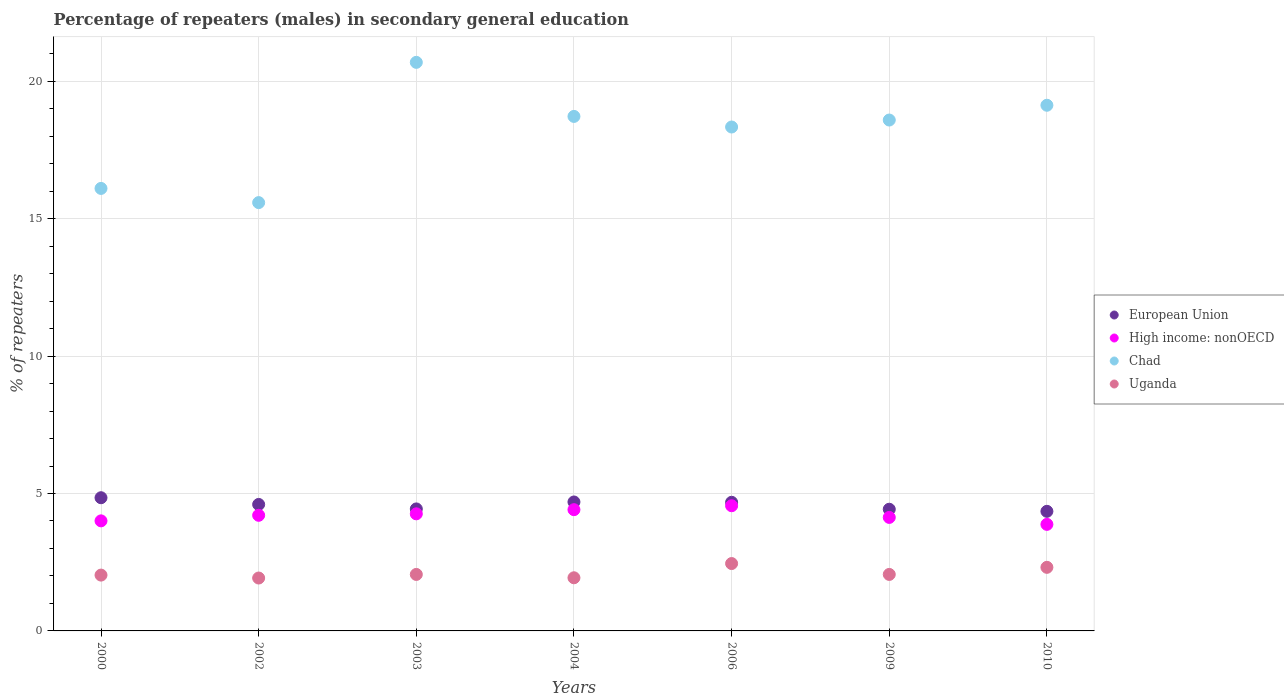How many different coloured dotlines are there?
Your response must be concise. 4. What is the percentage of male repeaters in Chad in 2009?
Ensure brevity in your answer.  18.59. Across all years, what is the maximum percentage of male repeaters in Uganda?
Make the answer very short. 2.45. Across all years, what is the minimum percentage of male repeaters in European Union?
Offer a very short reply. 4.35. In which year was the percentage of male repeaters in High income: nonOECD maximum?
Keep it short and to the point. 2006. What is the total percentage of male repeaters in High income: nonOECD in the graph?
Ensure brevity in your answer.  29.44. What is the difference between the percentage of male repeaters in Uganda in 2000 and that in 2006?
Make the answer very short. -0.42. What is the difference between the percentage of male repeaters in Chad in 2000 and the percentage of male repeaters in High income: nonOECD in 2009?
Provide a short and direct response. 11.97. What is the average percentage of male repeaters in Chad per year?
Provide a short and direct response. 18.16. In the year 2009, what is the difference between the percentage of male repeaters in High income: nonOECD and percentage of male repeaters in Uganda?
Provide a succinct answer. 2.07. In how many years, is the percentage of male repeaters in Uganda greater than 8 %?
Offer a terse response. 0. What is the ratio of the percentage of male repeaters in Uganda in 2003 to that in 2010?
Offer a terse response. 0.89. Is the percentage of male repeaters in High income: nonOECD in 2002 less than that in 2010?
Give a very brief answer. No. Is the difference between the percentage of male repeaters in High income: nonOECD in 2002 and 2006 greater than the difference between the percentage of male repeaters in Uganda in 2002 and 2006?
Ensure brevity in your answer.  Yes. What is the difference between the highest and the second highest percentage of male repeaters in High income: nonOECD?
Ensure brevity in your answer.  0.14. What is the difference between the highest and the lowest percentage of male repeaters in High income: nonOECD?
Provide a short and direct response. 0.68. Is the sum of the percentage of male repeaters in Uganda in 2009 and 2010 greater than the maximum percentage of male repeaters in High income: nonOECD across all years?
Offer a very short reply. No. Is it the case that in every year, the sum of the percentage of male repeaters in Uganda and percentage of male repeaters in Chad  is greater than the sum of percentage of male repeaters in High income: nonOECD and percentage of male repeaters in European Union?
Keep it short and to the point. Yes. Is it the case that in every year, the sum of the percentage of male repeaters in Uganda and percentage of male repeaters in Chad  is greater than the percentage of male repeaters in European Union?
Make the answer very short. Yes. What is the difference between two consecutive major ticks on the Y-axis?
Your response must be concise. 5. How many legend labels are there?
Your answer should be very brief. 4. How are the legend labels stacked?
Keep it short and to the point. Vertical. What is the title of the graph?
Make the answer very short. Percentage of repeaters (males) in secondary general education. What is the label or title of the Y-axis?
Your answer should be compact. % of repeaters. What is the % of repeaters of European Union in 2000?
Offer a very short reply. 4.85. What is the % of repeaters in High income: nonOECD in 2000?
Offer a terse response. 4. What is the % of repeaters in Chad in 2000?
Offer a very short reply. 16.1. What is the % of repeaters in Uganda in 2000?
Provide a succinct answer. 2.03. What is the % of repeaters of European Union in 2002?
Offer a terse response. 4.6. What is the % of repeaters of High income: nonOECD in 2002?
Your response must be concise. 4.21. What is the % of repeaters of Chad in 2002?
Provide a short and direct response. 15.58. What is the % of repeaters of Uganda in 2002?
Your response must be concise. 1.92. What is the % of repeaters in European Union in 2003?
Your answer should be very brief. 4.44. What is the % of repeaters in High income: nonOECD in 2003?
Ensure brevity in your answer.  4.26. What is the % of repeaters in Chad in 2003?
Offer a very short reply. 20.69. What is the % of repeaters of Uganda in 2003?
Your response must be concise. 2.06. What is the % of repeaters of European Union in 2004?
Give a very brief answer. 4.69. What is the % of repeaters of High income: nonOECD in 2004?
Your answer should be compact. 4.41. What is the % of repeaters in Chad in 2004?
Provide a short and direct response. 18.72. What is the % of repeaters of Uganda in 2004?
Make the answer very short. 1.93. What is the % of repeaters of European Union in 2006?
Offer a very short reply. 4.68. What is the % of repeaters of High income: nonOECD in 2006?
Offer a terse response. 4.55. What is the % of repeaters in Chad in 2006?
Provide a succinct answer. 18.33. What is the % of repeaters of Uganda in 2006?
Offer a very short reply. 2.45. What is the % of repeaters in European Union in 2009?
Your response must be concise. 4.43. What is the % of repeaters of High income: nonOECD in 2009?
Your answer should be compact. 4.13. What is the % of repeaters of Chad in 2009?
Your response must be concise. 18.59. What is the % of repeaters of Uganda in 2009?
Offer a very short reply. 2.06. What is the % of repeaters in European Union in 2010?
Give a very brief answer. 4.35. What is the % of repeaters of High income: nonOECD in 2010?
Provide a succinct answer. 3.88. What is the % of repeaters in Chad in 2010?
Give a very brief answer. 19.13. What is the % of repeaters in Uganda in 2010?
Your response must be concise. 2.31. Across all years, what is the maximum % of repeaters of European Union?
Your response must be concise. 4.85. Across all years, what is the maximum % of repeaters of High income: nonOECD?
Provide a short and direct response. 4.55. Across all years, what is the maximum % of repeaters in Chad?
Provide a short and direct response. 20.69. Across all years, what is the maximum % of repeaters of Uganda?
Your answer should be very brief. 2.45. Across all years, what is the minimum % of repeaters of European Union?
Offer a very short reply. 4.35. Across all years, what is the minimum % of repeaters of High income: nonOECD?
Ensure brevity in your answer.  3.88. Across all years, what is the minimum % of repeaters in Chad?
Your answer should be very brief. 15.58. Across all years, what is the minimum % of repeaters in Uganda?
Your answer should be compact. 1.92. What is the total % of repeaters in European Union in the graph?
Keep it short and to the point. 32.04. What is the total % of repeaters in High income: nonOECD in the graph?
Your answer should be very brief. 29.44. What is the total % of repeaters in Chad in the graph?
Offer a very short reply. 127.14. What is the total % of repeaters of Uganda in the graph?
Provide a short and direct response. 14.77. What is the difference between the % of repeaters in European Union in 2000 and that in 2002?
Your answer should be very brief. 0.24. What is the difference between the % of repeaters in High income: nonOECD in 2000 and that in 2002?
Your answer should be compact. -0.2. What is the difference between the % of repeaters of Chad in 2000 and that in 2002?
Provide a short and direct response. 0.52. What is the difference between the % of repeaters of Uganda in 2000 and that in 2002?
Your answer should be compact. 0.11. What is the difference between the % of repeaters of European Union in 2000 and that in 2003?
Give a very brief answer. 0.41. What is the difference between the % of repeaters in High income: nonOECD in 2000 and that in 2003?
Offer a terse response. -0.26. What is the difference between the % of repeaters in Chad in 2000 and that in 2003?
Keep it short and to the point. -4.59. What is the difference between the % of repeaters of Uganda in 2000 and that in 2003?
Your answer should be very brief. -0.02. What is the difference between the % of repeaters of European Union in 2000 and that in 2004?
Provide a succinct answer. 0.15. What is the difference between the % of repeaters in High income: nonOECD in 2000 and that in 2004?
Provide a short and direct response. -0.41. What is the difference between the % of repeaters of Chad in 2000 and that in 2004?
Make the answer very short. -2.62. What is the difference between the % of repeaters of Uganda in 2000 and that in 2004?
Ensure brevity in your answer.  0.1. What is the difference between the % of repeaters of European Union in 2000 and that in 2006?
Make the answer very short. 0.17. What is the difference between the % of repeaters of High income: nonOECD in 2000 and that in 2006?
Provide a short and direct response. -0.55. What is the difference between the % of repeaters in Chad in 2000 and that in 2006?
Provide a short and direct response. -2.23. What is the difference between the % of repeaters of Uganda in 2000 and that in 2006?
Give a very brief answer. -0.42. What is the difference between the % of repeaters in European Union in 2000 and that in 2009?
Ensure brevity in your answer.  0.42. What is the difference between the % of repeaters of High income: nonOECD in 2000 and that in 2009?
Offer a very short reply. -0.13. What is the difference between the % of repeaters of Chad in 2000 and that in 2009?
Your answer should be very brief. -2.49. What is the difference between the % of repeaters of Uganda in 2000 and that in 2009?
Offer a terse response. -0.02. What is the difference between the % of repeaters in European Union in 2000 and that in 2010?
Your answer should be compact. 0.49. What is the difference between the % of repeaters of High income: nonOECD in 2000 and that in 2010?
Offer a terse response. 0.13. What is the difference between the % of repeaters of Chad in 2000 and that in 2010?
Your response must be concise. -3.03. What is the difference between the % of repeaters in Uganda in 2000 and that in 2010?
Provide a succinct answer. -0.28. What is the difference between the % of repeaters in European Union in 2002 and that in 2003?
Make the answer very short. 0.16. What is the difference between the % of repeaters of High income: nonOECD in 2002 and that in 2003?
Give a very brief answer. -0.05. What is the difference between the % of repeaters in Chad in 2002 and that in 2003?
Provide a succinct answer. -5.1. What is the difference between the % of repeaters of Uganda in 2002 and that in 2003?
Your response must be concise. -0.13. What is the difference between the % of repeaters in European Union in 2002 and that in 2004?
Your response must be concise. -0.09. What is the difference between the % of repeaters in High income: nonOECD in 2002 and that in 2004?
Provide a short and direct response. -0.2. What is the difference between the % of repeaters of Chad in 2002 and that in 2004?
Ensure brevity in your answer.  -3.14. What is the difference between the % of repeaters in Uganda in 2002 and that in 2004?
Make the answer very short. -0.01. What is the difference between the % of repeaters in European Union in 2002 and that in 2006?
Ensure brevity in your answer.  -0.08. What is the difference between the % of repeaters in High income: nonOECD in 2002 and that in 2006?
Keep it short and to the point. -0.35. What is the difference between the % of repeaters of Chad in 2002 and that in 2006?
Your answer should be compact. -2.75. What is the difference between the % of repeaters of Uganda in 2002 and that in 2006?
Keep it short and to the point. -0.53. What is the difference between the % of repeaters in European Union in 2002 and that in 2009?
Provide a succinct answer. 0.17. What is the difference between the % of repeaters in High income: nonOECD in 2002 and that in 2009?
Make the answer very short. 0.08. What is the difference between the % of repeaters in Chad in 2002 and that in 2009?
Your answer should be compact. -3. What is the difference between the % of repeaters of Uganda in 2002 and that in 2009?
Provide a succinct answer. -0.13. What is the difference between the % of repeaters of European Union in 2002 and that in 2010?
Ensure brevity in your answer.  0.25. What is the difference between the % of repeaters of High income: nonOECD in 2002 and that in 2010?
Make the answer very short. 0.33. What is the difference between the % of repeaters in Chad in 2002 and that in 2010?
Provide a short and direct response. -3.54. What is the difference between the % of repeaters in Uganda in 2002 and that in 2010?
Provide a succinct answer. -0.39. What is the difference between the % of repeaters in European Union in 2003 and that in 2004?
Make the answer very short. -0.25. What is the difference between the % of repeaters in High income: nonOECD in 2003 and that in 2004?
Provide a short and direct response. -0.15. What is the difference between the % of repeaters in Chad in 2003 and that in 2004?
Provide a succinct answer. 1.97. What is the difference between the % of repeaters in Uganda in 2003 and that in 2004?
Provide a succinct answer. 0.12. What is the difference between the % of repeaters in European Union in 2003 and that in 2006?
Offer a very short reply. -0.24. What is the difference between the % of repeaters of High income: nonOECD in 2003 and that in 2006?
Ensure brevity in your answer.  -0.29. What is the difference between the % of repeaters of Chad in 2003 and that in 2006?
Offer a very short reply. 2.35. What is the difference between the % of repeaters in Uganda in 2003 and that in 2006?
Provide a short and direct response. -0.4. What is the difference between the % of repeaters of European Union in 2003 and that in 2009?
Your response must be concise. 0.01. What is the difference between the % of repeaters in High income: nonOECD in 2003 and that in 2009?
Provide a short and direct response. 0.13. What is the difference between the % of repeaters of Chad in 2003 and that in 2009?
Your response must be concise. 2.1. What is the difference between the % of repeaters of European Union in 2003 and that in 2010?
Your response must be concise. 0.09. What is the difference between the % of repeaters in High income: nonOECD in 2003 and that in 2010?
Your answer should be compact. 0.38. What is the difference between the % of repeaters in Chad in 2003 and that in 2010?
Your answer should be very brief. 1.56. What is the difference between the % of repeaters in Uganda in 2003 and that in 2010?
Make the answer very short. -0.26. What is the difference between the % of repeaters of European Union in 2004 and that in 2006?
Make the answer very short. 0.01. What is the difference between the % of repeaters of High income: nonOECD in 2004 and that in 2006?
Make the answer very short. -0.14. What is the difference between the % of repeaters of Chad in 2004 and that in 2006?
Provide a succinct answer. 0.39. What is the difference between the % of repeaters in Uganda in 2004 and that in 2006?
Provide a succinct answer. -0.52. What is the difference between the % of repeaters of European Union in 2004 and that in 2009?
Give a very brief answer. 0.26. What is the difference between the % of repeaters of High income: nonOECD in 2004 and that in 2009?
Offer a terse response. 0.28. What is the difference between the % of repeaters in Chad in 2004 and that in 2009?
Your answer should be compact. 0.13. What is the difference between the % of repeaters of Uganda in 2004 and that in 2009?
Your response must be concise. -0.12. What is the difference between the % of repeaters of European Union in 2004 and that in 2010?
Your answer should be very brief. 0.34. What is the difference between the % of repeaters of High income: nonOECD in 2004 and that in 2010?
Give a very brief answer. 0.53. What is the difference between the % of repeaters of Chad in 2004 and that in 2010?
Offer a very short reply. -0.41. What is the difference between the % of repeaters in Uganda in 2004 and that in 2010?
Your answer should be compact. -0.38. What is the difference between the % of repeaters of European Union in 2006 and that in 2009?
Your answer should be compact. 0.25. What is the difference between the % of repeaters in High income: nonOECD in 2006 and that in 2009?
Your answer should be very brief. 0.42. What is the difference between the % of repeaters of Chad in 2006 and that in 2009?
Give a very brief answer. -0.25. What is the difference between the % of repeaters of Uganda in 2006 and that in 2009?
Provide a short and direct response. 0.4. What is the difference between the % of repeaters in European Union in 2006 and that in 2010?
Provide a short and direct response. 0.33. What is the difference between the % of repeaters in High income: nonOECD in 2006 and that in 2010?
Provide a succinct answer. 0.68. What is the difference between the % of repeaters of Chad in 2006 and that in 2010?
Provide a succinct answer. -0.79. What is the difference between the % of repeaters in Uganda in 2006 and that in 2010?
Make the answer very short. 0.14. What is the difference between the % of repeaters in European Union in 2009 and that in 2010?
Offer a very short reply. 0.08. What is the difference between the % of repeaters of High income: nonOECD in 2009 and that in 2010?
Your answer should be compact. 0.25. What is the difference between the % of repeaters of Chad in 2009 and that in 2010?
Your answer should be very brief. -0.54. What is the difference between the % of repeaters of Uganda in 2009 and that in 2010?
Your answer should be very brief. -0.26. What is the difference between the % of repeaters of European Union in 2000 and the % of repeaters of High income: nonOECD in 2002?
Your response must be concise. 0.64. What is the difference between the % of repeaters of European Union in 2000 and the % of repeaters of Chad in 2002?
Offer a terse response. -10.74. What is the difference between the % of repeaters in European Union in 2000 and the % of repeaters in Uganda in 2002?
Your answer should be very brief. 2.92. What is the difference between the % of repeaters of High income: nonOECD in 2000 and the % of repeaters of Chad in 2002?
Your response must be concise. -11.58. What is the difference between the % of repeaters of High income: nonOECD in 2000 and the % of repeaters of Uganda in 2002?
Keep it short and to the point. 2.08. What is the difference between the % of repeaters of Chad in 2000 and the % of repeaters of Uganda in 2002?
Ensure brevity in your answer.  14.18. What is the difference between the % of repeaters of European Union in 2000 and the % of repeaters of High income: nonOECD in 2003?
Give a very brief answer. 0.59. What is the difference between the % of repeaters of European Union in 2000 and the % of repeaters of Chad in 2003?
Offer a very short reply. -15.84. What is the difference between the % of repeaters of European Union in 2000 and the % of repeaters of Uganda in 2003?
Ensure brevity in your answer.  2.79. What is the difference between the % of repeaters in High income: nonOECD in 2000 and the % of repeaters in Chad in 2003?
Provide a short and direct response. -16.68. What is the difference between the % of repeaters in High income: nonOECD in 2000 and the % of repeaters in Uganda in 2003?
Give a very brief answer. 1.95. What is the difference between the % of repeaters of Chad in 2000 and the % of repeaters of Uganda in 2003?
Provide a succinct answer. 14.04. What is the difference between the % of repeaters of European Union in 2000 and the % of repeaters of High income: nonOECD in 2004?
Ensure brevity in your answer.  0.43. What is the difference between the % of repeaters of European Union in 2000 and the % of repeaters of Chad in 2004?
Your answer should be compact. -13.87. What is the difference between the % of repeaters in European Union in 2000 and the % of repeaters in Uganda in 2004?
Provide a short and direct response. 2.91. What is the difference between the % of repeaters of High income: nonOECD in 2000 and the % of repeaters of Chad in 2004?
Offer a terse response. -14.72. What is the difference between the % of repeaters of High income: nonOECD in 2000 and the % of repeaters of Uganda in 2004?
Your answer should be compact. 2.07. What is the difference between the % of repeaters in Chad in 2000 and the % of repeaters in Uganda in 2004?
Make the answer very short. 14.17. What is the difference between the % of repeaters of European Union in 2000 and the % of repeaters of High income: nonOECD in 2006?
Your answer should be very brief. 0.29. What is the difference between the % of repeaters in European Union in 2000 and the % of repeaters in Chad in 2006?
Offer a terse response. -13.49. What is the difference between the % of repeaters of European Union in 2000 and the % of repeaters of Uganda in 2006?
Your answer should be compact. 2.39. What is the difference between the % of repeaters in High income: nonOECD in 2000 and the % of repeaters in Chad in 2006?
Provide a short and direct response. -14.33. What is the difference between the % of repeaters in High income: nonOECD in 2000 and the % of repeaters in Uganda in 2006?
Offer a terse response. 1.55. What is the difference between the % of repeaters of Chad in 2000 and the % of repeaters of Uganda in 2006?
Offer a terse response. 13.65. What is the difference between the % of repeaters in European Union in 2000 and the % of repeaters in High income: nonOECD in 2009?
Make the answer very short. 0.72. What is the difference between the % of repeaters in European Union in 2000 and the % of repeaters in Chad in 2009?
Your response must be concise. -13.74. What is the difference between the % of repeaters in European Union in 2000 and the % of repeaters in Uganda in 2009?
Keep it short and to the point. 2.79. What is the difference between the % of repeaters in High income: nonOECD in 2000 and the % of repeaters in Chad in 2009?
Ensure brevity in your answer.  -14.58. What is the difference between the % of repeaters in High income: nonOECD in 2000 and the % of repeaters in Uganda in 2009?
Provide a succinct answer. 1.95. What is the difference between the % of repeaters in Chad in 2000 and the % of repeaters in Uganda in 2009?
Offer a very short reply. 14.04. What is the difference between the % of repeaters in European Union in 2000 and the % of repeaters in High income: nonOECD in 2010?
Offer a very short reply. 0.97. What is the difference between the % of repeaters of European Union in 2000 and the % of repeaters of Chad in 2010?
Ensure brevity in your answer.  -14.28. What is the difference between the % of repeaters in European Union in 2000 and the % of repeaters in Uganda in 2010?
Make the answer very short. 2.53. What is the difference between the % of repeaters in High income: nonOECD in 2000 and the % of repeaters in Chad in 2010?
Your answer should be compact. -15.12. What is the difference between the % of repeaters in High income: nonOECD in 2000 and the % of repeaters in Uganda in 2010?
Offer a very short reply. 1.69. What is the difference between the % of repeaters in Chad in 2000 and the % of repeaters in Uganda in 2010?
Provide a short and direct response. 13.79. What is the difference between the % of repeaters in European Union in 2002 and the % of repeaters in High income: nonOECD in 2003?
Your answer should be compact. 0.34. What is the difference between the % of repeaters of European Union in 2002 and the % of repeaters of Chad in 2003?
Offer a very short reply. -16.08. What is the difference between the % of repeaters of European Union in 2002 and the % of repeaters of Uganda in 2003?
Provide a short and direct response. 2.55. What is the difference between the % of repeaters of High income: nonOECD in 2002 and the % of repeaters of Chad in 2003?
Ensure brevity in your answer.  -16.48. What is the difference between the % of repeaters of High income: nonOECD in 2002 and the % of repeaters of Uganda in 2003?
Your answer should be very brief. 2.15. What is the difference between the % of repeaters of Chad in 2002 and the % of repeaters of Uganda in 2003?
Offer a very short reply. 13.53. What is the difference between the % of repeaters in European Union in 2002 and the % of repeaters in High income: nonOECD in 2004?
Provide a succinct answer. 0.19. What is the difference between the % of repeaters of European Union in 2002 and the % of repeaters of Chad in 2004?
Offer a terse response. -14.12. What is the difference between the % of repeaters in European Union in 2002 and the % of repeaters in Uganda in 2004?
Your answer should be very brief. 2.67. What is the difference between the % of repeaters in High income: nonOECD in 2002 and the % of repeaters in Chad in 2004?
Offer a very short reply. -14.51. What is the difference between the % of repeaters of High income: nonOECD in 2002 and the % of repeaters of Uganda in 2004?
Provide a succinct answer. 2.27. What is the difference between the % of repeaters of Chad in 2002 and the % of repeaters of Uganda in 2004?
Make the answer very short. 13.65. What is the difference between the % of repeaters in European Union in 2002 and the % of repeaters in High income: nonOECD in 2006?
Offer a very short reply. 0.05. What is the difference between the % of repeaters in European Union in 2002 and the % of repeaters in Chad in 2006?
Ensure brevity in your answer.  -13.73. What is the difference between the % of repeaters in European Union in 2002 and the % of repeaters in Uganda in 2006?
Your response must be concise. 2.15. What is the difference between the % of repeaters in High income: nonOECD in 2002 and the % of repeaters in Chad in 2006?
Offer a very short reply. -14.13. What is the difference between the % of repeaters of High income: nonOECD in 2002 and the % of repeaters of Uganda in 2006?
Ensure brevity in your answer.  1.76. What is the difference between the % of repeaters in Chad in 2002 and the % of repeaters in Uganda in 2006?
Provide a short and direct response. 13.13. What is the difference between the % of repeaters in European Union in 2002 and the % of repeaters in High income: nonOECD in 2009?
Offer a very short reply. 0.47. What is the difference between the % of repeaters in European Union in 2002 and the % of repeaters in Chad in 2009?
Keep it short and to the point. -13.99. What is the difference between the % of repeaters in European Union in 2002 and the % of repeaters in Uganda in 2009?
Ensure brevity in your answer.  2.55. What is the difference between the % of repeaters in High income: nonOECD in 2002 and the % of repeaters in Chad in 2009?
Provide a succinct answer. -14.38. What is the difference between the % of repeaters in High income: nonOECD in 2002 and the % of repeaters in Uganda in 2009?
Your answer should be compact. 2.15. What is the difference between the % of repeaters of Chad in 2002 and the % of repeaters of Uganda in 2009?
Provide a short and direct response. 13.53. What is the difference between the % of repeaters in European Union in 2002 and the % of repeaters in High income: nonOECD in 2010?
Keep it short and to the point. 0.73. What is the difference between the % of repeaters of European Union in 2002 and the % of repeaters of Chad in 2010?
Your answer should be very brief. -14.52. What is the difference between the % of repeaters of European Union in 2002 and the % of repeaters of Uganda in 2010?
Provide a short and direct response. 2.29. What is the difference between the % of repeaters in High income: nonOECD in 2002 and the % of repeaters in Chad in 2010?
Offer a very short reply. -14.92. What is the difference between the % of repeaters in High income: nonOECD in 2002 and the % of repeaters in Uganda in 2010?
Offer a very short reply. 1.89. What is the difference between the % of repeaters in Chad in 2002 and the % of repeaters in Uganda in 2010?
Give a very brief answer. 13.27. What is the difference between the % of repeaters in European Union in 2003 and the % of repeaters in High income: nonOECD in 2004?
Ensure brevity in your answer.  0.03. What is the difference between the % of repeaters of European Union in 2003 and the % of repeaters of Chad in 2004?
Keep it short and to the point. -14.28. What is the difference between the % of repeaters of European Union in 2003 and the % of repeaters of Uganda in 2004?
Offer a terse response. 2.51. What is the difference between the % of repeaters of High income: nonOECD in 2003 and the % of repeaters of Chad in 2004?
Your response must be concise. -14.46. What is the difference between the % of repeaters in High income: nonOECD in 2003 and the % of repeaters in Uganda in 2004?
Offer a very short reply. 2.33. What is the difference between the % of repeaters of Chad in 2003 and the % of repeaters of Uganda in 2004?
Offer a terse response. 18.75. What is the difference between the % of repeaters of European Union in 2003 and the % of repeaters of High income: nonOECD in 2006?
Give a very brief answer. -0.12. What is the difference between the % of repeaters of European Union in 2003 and the % of repeaters of Chad in 2006?
Ensure brevity in your answer.  -13.9. What is the difference between the % of repeaters in European Union in 2003 and the % of repeaters in Uganda in 2006?
Your answer should be very brief. 1.99. What is the difference between the % of repeaters of High income: nonOECD in 2003 and the % of repeaters of Chad in 2006?
Make the answer very short. -14.07. What is the difference between the % of repeaters of High income: nonOECD in 2003 and the % of repeaters of Uganda in 2006?
Make the answer very short. 1.81. What is the difference between the % of repeaters of Chad in 2003 and the % of repeaters of Uganda in 2006?
Your answer should be compact. 18.24. What is the difference between the % of repeaters of European Union in 2003 and the % of repeaters of High income: nonOECD in 2009?
Offer a very short reply. 0.31. What is the difference between the % of repeaters in European Union in 2003 and the % of repeaters in Chad in 2009?
Your answer should be compact. -14.15. What is the difference between the % of repeaters in European Union in 2003 and the % of repeaters in Uganda in 2009?
Provide a succinct answer. 2.38. What is the difference between the % of repeaters of High income: nonOECD in 2003 and the % of repeaters of Chad in 2009?
Ensure brevity in your answer.  -14.33. What is the difference between the % of repeaters in High income: nonOECD in 2003 and the % of repeaters in Uganda in 2009?
Ensure brevity in your answer.  2.2. What is the difference between the % of repeaters of Chad in 2003 and the % of repeaters of Uganda in 2009?
Give a very brief answer. 18.63. What is the difference between the % of repeaters of European Union in 2003 and the % of repeaters of High income: nonOECD in 2010?
Your answer should be compact. 0.56. What is the difference between the % of repeaters of European Union in 2003 and the % of repeaters of Chad in 2010?
Your response must be concise. -14.69. What is the difference between the % of repeaters of European Union in 2003 and the % of repeaters of Uganda in 2010?
Offer a very short reply. 2.13. What is the difference between the % of repeaters of High income: nonOECD in 2003 and the % of repeaters of Chad in 2010?
Provide a succinct answer. -14.87. What is the difference between the % of repeaters in High income: nonOECD in 2003 and the % of repeaters in Uganda in 2010?
Ensure brevity in your answer.  1.95. What is the difference between the % of repeaters in Chad in 2003 and the % of repeaters in Uganda in 2010?
Keep it short and to the point. 18.37. What is the difference between the % of repeaters in European Union in 2004 and the % of repeaters in High income: nonOECD in 2006?
Offer a terse response. 0.14. What is the difference between the % of repeaters of European Union in 2004 and the % of repeaters of Chad in 2006?
Make the answer very short. -13.64. What is the difference between the % of repeaters in European Union in 2004 and the % of repeaters in Uganda in 2006?
Offer a very short reply. 2.24. What is the difference between the % of repeaters in High income: nonOECD in 2004 and the % of repeaters in Chad in 2006?
Your response must be concise. -13.92. What is the difference between the % of repeaters of High income: nonOECD in 2004 and the % of repeaters of Uganda in 2006?
Your response must be concise. 1.96. What is the difference between the % of repeaters in Chad in 2004 and the % of repeaters in Uganda in 2006?
Ensure brevity in your answer.  16.27. What is the difference between the % of repeaters of European Union in 2004 and the % of repeaters of High income: nonOECD in 2009?
Provide a succinct answer. 0.56. What is the difference between the % of repeaters in European Union in 2004 and the % of repeaters in Chad in 2009?
Ensure brevity in your answer.  -13.9. What is the difference between the % of repeaters in European Union in 2004 and the % of repeaters in Uganda in 2009?
Your answer should be compact. 2.64. What is the difference between the % of repeaters of High income: nonOECD in 2004 and the % of repeaters of Chad in 2009?
Keep it short and to the point. -14.18. What is the difference between the % of repeaters of High income: nonOECD in 2004 and the % of repeaters of Uganda in 2009?
Provide a short and direct response. 2.36. What is the difference between the % of repeaters in Chad in 2004 and the % of repeaters in Uganda in 2009?
Give a very brief answer. 16.66. What is the difference between the % of repeaters in European Union in 2004 and the % of repeaters in High income: nonOECD in 2010?
Give a very brief answer. 0.81. What is the difference between the % of repeaters of European Union in 2004 and the % of repeaters of Chad in 2010?
Give a very brief answer. -14.43. What is the difference between the % of repeaters in European Union in 2004 and the % of repeaters in Uganda in 2010?
Offer a terse response. 2.38. What is the difference between the % of repeaters in High income: nonOECD in 2004 and the % of repeaters in Chad in 2010?
Keep it short and to the point. -14.71. What is the difference between the % of repeaters of High income: nonOECD in 2004 and the % of repeaters of Uganda in 2010?
Make the answer very short. 2.1. What is the difference between the % of repeaters of Chad in 2004 and the % of repeaters of Uganda in 2010?
Your answer should be very brief. 16.41. What is the difference between the % of repeaters of European Union in 2006 and the % of repeaters of High income: nonOECD in 2009?
Make the answer very short. 0.55. What is the difference between the % of repeaters of European Union in 2006 and the % of repeaters of Chad in 2009?
Offer a terse response. -13.91. What is the difference between the % of repeaters in European Union in 2006 and the % of repeaters in Uganda in 2009?
Provide a succinct answer. 2.62. What is the difference between the % of repeaters of High income: nonOECD in 2006 and the % of repeaters of Chad in 2009?
Offer a very short reply. -14.03. What is the difference between the % of repeaters of High income: nonOECD in 2006 and the % of repeaters of Uganda in 2009?
Your answer should be compact. 2.5. What is the difference between the % of repeaters of Chad in 2006 and the % of repeaters of Uganda in 2009?
Ensure brevity in your answer.  16.28. What is the difference between the % of repeaters in European Union in 2006 and the % of repeaters in High income: nonOECD in 2010?
Provide a succinct answer. 0.8. What is the difference between the % of repeaters of European Union in 2006 and the % of repeaters of Chad in 2010?
Make the answer very short. -14.45. What is the difference between the % of repeaters of European Union in 2006 and the % of repeaters of Uganda in 2010?
Your answer should be very brief. 2.37. What is the difference between the % of repeaters of High income: nonOECD in 2006 and the % of repeaters of Chad in 2010?
Your answer should be very brief. -14.57. What is the difference between the % of repeaters in High income: nonOECD in 2006 and the % of repeaters in Uganda in 2010?
Offer a very short reply. 2.24. What is the difference between the % of repeaters of Chad in 2006 and the % of repeaters of Uganda in 2010?
Give a very brief answer. 16.02. What is the difference between the % of repeaters in European Union in 2009 and the % of repeaters in High income: nonOECD in 2010?
Ensure brevity in your answer.  0.55. What is the difference between the % of repeaters of European Union in 2009 and the % of repeaters of Chad in 2010?
Provide a succinct answer. -14.7. What is the difference between the % of repeaters of European Union in 2009 and the % of repeaters of Uganda in 2010?
Your response must be concise. 2.11. What is the difference between the % of repeaters of High income: nonOECD in 2009 and the % of repeaters of Chad in 2010?
Your answer should be compact. -15. What is the difference between the % of repeaters in High income: nonOECD in 2009 and the % of repeaters in Uganda in 2010?
Offer a very short reply. 1.82. What is the difference between the % of repeaters of Chad in 2009 and the % of repeaters of Uganda in 2010?
Offer a very short reply. 16.27. What is the average % of repeaters in European Union per year?
Your answer should be very brief. 4.58. What is the average % of repeaters in High income: nonOECD per year?
Make the answer very short. 4.21. What is the average % of repeaters in Chad per year?
Ensure brevity in your answer.  18.16. What is the average % of repeaters in Uganda per year?
Your answer should be compact. 2.11. In the year 2000, what is the difference between the % of repeaters of European Union and % of repeaters of High income: nonOECD?
Your response must be concise. 0.84. In the year 2000, what is the difference between the % of repeaters of European Union and % of repeaters of Chad?
Provide a short and direct response. -11.25. In the year 2000, what is the difference between the % of repeaters in European Union and % of repeaters in Uganda?
Provide a short and direct response. 2.81. In the year 2000, what is the difference between the % of repeaters in High income: nonOECD and % of repeaters in Chad?
Give a very brief answer. -12.1. In the year 2000, what is the difference between the % of repeaters in High income: nonOECD and % of repeaters in Uganda?
Your response must be concise. 1.97. In the year 2000, what is the difference between the % of repeaters of Chad and % of repeaters of Uganda?
Ensure brevity in your answer.  14.07. In the year 2002, what is the difference between the % of repeaters in European Union and % of repeaters in High income: nonOECD?
Offer a terse response. 0.4. In the year 2002, what is the difference between the % of repeaters in European Union and % of repeaters in Chad?
Offer a terse response. -10.98. In the year 2002, what is the difference between the % of repeaters of European Union and % of repeaters of Uganda?
Give a very brief answer. 2.68. In the year 2002, what is the difference between the % of repeaters in High income: nonOECD and % of repeaters in Chad?
Make the answer very short. -11.38. In the year 2002, what is the difference between the % of repeaters of High income: nonOECD and % of repeaters of Uganda?
Your response must be concise. 2.28. In the year 2002, what is the difference between the % of repeaters of Chad and % of repeaters of Uganda?
Ensure brevity in your answer.  13.66. In the year 2003, what is the difference between the % of repeaters in European Union and % of repeaters in High income: nonOECD?
Keep it short and to the point. 0.18. In the year 2003, what is the difference between the % of repeaters in European Union and % of repeaters in Chad?
Make the answer very short. -16.25. In the year 2003, what is the difference between the % of repeaters in European Union and % of repeaters in Uganda?
Provide a short and direct response. 2.38. In the year 2003, what is the difference between the % of repeaters of High income: nonOECD and % of repeaters of Chad?
Provide a succinct answer. -16.43. In the year 2003, what is the difference between the % of repeaters in High income: nonOECD and % of repeaters in Uganda?
Make the answer very short. 2.2. In the year 2003, what is the difference between the % of repeaters in Chad and % of repeaters in Uganda?
Provide a short and direct response. 18.63. In the year 2004, what is the difference between the % of repeaters of European Union and % of repeaters of High income: nonOECD?
Make the answer very short. 0.28. In the year 2004, what is the difference between the % of repeaters in European Union and % of repeaters in Chad?
Make the answer very short. -14.03. In the year 2004, what is the difference between the % of repeaters in European Union and % of repeaters in Uganda?
Offer a very short reply. 2.76. In the year 2004, what is the difference between the % of repeaters in High income: nonOECD and % of repeaters in Chad?
Offer a terse response. -14.31. In the year 2004, what is the difference between the % of repeaters in High income: nonOECD and % of repeaters in Uganda?
Provide a succinct answer. 2.48. In the year 2004, what is the difference between the % of repeaters of Chad and % of repeaters of Uganda?
Give a very brief answer. 16.79. In the year 2006, what is the difference between the % of repeaters of European Union and % of repeaters of High income: nonOECD?
Make the answer very short. 0.13. In the year 2006, what is the difference between the % of repeaters in European Union and % of repeaters in Chad?
Provide a succinct answer. -13.65. In the year 2006, what is the difference between the % of repeaters in European Union and % of repeaters in Uganda?
Ensure brevity in your answer.  2.23. In the year 2006, what is the difference between the % of repeaters of High income: nonOECD and % of repeaters of Chad?
Provide a succinct answer. -13.78. In the year 2006, what is the difference between the % of repeaters of High income: nonOECD and % of repeaters of Uganda?
Your response must be concise. 2.1. In the year 2006, what is the difference between the % of repeaters in Chad and % of repeaters in Uganda?
Your answer should be very brief. 15.88. In the year 2009, what is the difference between the % of repeaters in European Union and % of repeaters in High income: nonOECD?
Provide a short and direct response. 0.3. In the year 2009, what is the difference between the % of repeaters of European Union and % of repeaters of Chad?
Offer a very short reply. -14.16. In the year 2009, what is the difference between the % of repeaters of European Union and % of repeaters of Uganda?
Make the answer very short. 2.37. In the year 2009, what is the difference between the % of repeaters in High income: nonOECD and % of repeaters in Chad?
Give a very brief answer. -14.46. In the year 2009, what is the difference between the % of repeaters of High income: nonOECD and % of repeaters of Uganda?
Offer a terse response. 2.07. In the year 2009, what is the difference between the % of repeaters in Chad and % of repeaters in Uganda?
Keep it short and to the point. 16.53. In the year 2010, what is the difference between the % of repeaters of European Union and % of repeaters of High income: nonOECD?
Offer a very short reply. 0.47. In the year 2010, what is the difference between the % of repeaters of European Union and % of repeaters of Chad?
Make the answer very short. -14.77. In the year 2010, what is the difference between the % of repeaters in European Union and % of repeaters in Uganda?
Give a very brief answer. 2.04. In the year 2010, what is the difference between the % of repeaters of High income: nonOECD and % of repeaters of Chad?
Make the answer very short. -15.25. In the year 2010, what is the difference between the % of repeaters of High income: nonOECD and % of repeaters of Uganda?
Keep it short and to the point. 1.56. In the year 2010, what is the difference between the % of repeaters of Chad and % of repeaters of Uganda?
Provide a succinct answer. 16.81. What is the ratio of the % of repeaters of European Union in 2000 to that in 2002?
Ensure brevity in your answer.  1.05. What is the ratio of the % of repeaters in High income: nonOECD in 2000 to that in 2002?
Provide a succinct answer. 0.95. What is the ratio of the % of repeaters in Chad in 2000 to that in 2002?
Provide a short and direct response. 1.03. What is the ratio of the % of repeaters of Uganda in 2000 to that in 2002?
Keep it short and to the point. 1.06. What is the ratio of the % of repeaters of European Union in 2000 to that in 2003?
Make the answer very short. 1.09. What is the ratio of the % of repeaters in Chad in 2000 to that in 2003?
Ensure brevity in your answer.  0.78. What is the ratio of the % of repeaters in European Union in 2000 to that in 2004?
Make the answer very short. 1.03. What is the ratio of the % of repeaters in High income: nonOECD in 2000 to that in 2004?
Give a very brief answer. 0.91. What is the ratio of the % of repeaters of Chad in 2000 to that in 2004?
Provide a short and direct response. 0.86. What is the ratio of the % of repeaters in Uganda in 2000 to that in 2004?
Ensure brevity in your answer.  1.05. What is the ratio of the % of repeaters of European Union in 2000 to that in 2006?
Keep it short and to the point. 1.04. What is the ratio of the % of repeaters of High income: nonOECD in 2000 to that in 2006?
Make the answer very short. 0.88. What is the ratio of the % of repeaters in Chad in 2000 to that in 2006?
Provide a short and direct response. 0.88. What is the ratio of the % of repeaters of Uganda in 2000 to that in 2006?
Your answer should be very brief. 0.83. What is the ratio of the % of repeaters of European Union in 2000 to that in 2009?
Make the answer very short. 1.09. What is the ratio of the % of repeaters of High income: nonOECD in 2000 to that in 2009?
Ensure brevity in your answer.  0.97. What is the ratio of the % of repeaters of Chad in 2000 to that in 2009?
Your answer should be compact. 0.87. What is the ratio of the % of repeaters of European Union in 2000 to that in 2010?
Make the answer very short. 1.11. What is the ratio of the % of repeaters of High income: nonOECD in 2000 to that in 2010?
Make the answer very short. 1.03. What is the ratio of the % of repeaters in Chad in 2000 to that in 2010?
Provide a succinct answer. 0.84. What is the ratio of the % of repeaters of Uganda in 2000 to that in 2010?
Ensure brevity in your answer.  0.88. What is the ratio of the % of repeaters of European Union in 2002 to that in 2003?
Ensure brevity in your answer.  1.04. What is the ratio of the % of repeaters in High income: nonOECD in 2002 to that in 2003?
Keep it short and to the point. 0.99. What is the ratio of the % of repeaters in Chad in 2002 to that in 2003?
Make the answer very short. 0.75. What is the ratio of the % of repeaters in Uganda in 2002 to that in 2003?
Your response must be concise. 0.94. What is the ratio of the % of repeaters of European Union in 2002 to that in 2004?
Keep it short and to the point. 0.98. What is the ratio of the % of repeaters in High income: nonOECD in 2002 to that in 2004?
Offer a very short reply. 0.95. What is the ratio of the % of repeaters of Chad in 2002 to that in 2004?
Your answer should be compact. 0.83. What is the ratio of the % of repeaters in European Union in 2002 to that in 2006?
Provide a succinct answer. 0.98. What is the ratio of the % of repeaters in High income: nonOECD in 2002 to that in 2006?
Provide a short and direct response. 0.92. What is the ratio of the % of repeaters in Chad in 2002 to that in 2006?
Your answer should be compact. 0.85. What is the ratio of the % of repeaters of Uganda in 2002 to that in 2006?
Offer a very short reply. 0.79. What is the ratio of the % of repeaters of European Union in 2002 to that in 2009?
Offer a very short reply. 1.04. What is the ratio of the % of repeaters of High income: nonOECD in 2002 to that in 2009?
Offer a very short reply. 1.02. What is the ratio of the % of repeaters of Chad in 2002 to that in 2009?
Offer a very short reply. 0.84. What is the ratio of the % of repeaters in Uganda in 2002 to that in 2009?
Offer a very short reply. 0.94. What is the ratio of the % of repeaters of European Union in 2002 to that in 2010?
Offer a very short reply. 1.06. What is the ratio of the % of repeaters in High income: nonOECD in 2002 to that in 2010?
Your answer should be very brief. 1.09. What is the ratio of the % of repeaters of Chad in 2002 to that in 2010?
Provide a succinct answer. 0.81. What is the ratio of the % of repeaters of Uganda in 2002 to that in 2010?
Your answer should be very brief. 0.83. What is the ratio of the % of repeaters of European Union in 2003 to that in 2004?
Your answer should be very brief. 0.95. What is the ratio of the % of repeaters of High income: nonOECD in 2003 to that in 2004?
Keep it short and to the point. 0.97. What is the ratio of the % of repeaters in Chad in 2003 to that in 2004?
Make the answer very short. 1.11. What is the ratio of the % of repeaters of Uganda in 2003 to that in 2004?
Keep it short and to the point. 1.06. What is the ratio of the % of repeaters in European Union in 2003 to that in 2006?
Give a very brief answer. 0.95. What is the ratio of the % of repeaters of High income: nonOECD in 2003 to that in 2006?
Give a very brief answer. 0.94. What is the ratio of the % of repeaters in Chad in 2003 to that in 2006?
Your answer should be compact. 1.13. What is the ratio of the % of repeaters in Uganda in 2003 to that in 2006?
Your answer should be very brief. 0.84. What is the ratio of the % of repeaters in European Union in 2003 to that in 2009?
Provide a short and direct response. 1. What is the ratio of the % of repeaters of High income: nonOECD in 2003 to that in 2009?
Make the answer very short. 1.03. What is the ratio of the % of repeaters of Chad in 2003 to that in 2009?
Offer a terse response. 1.11. What is the ratio of the % of repeaters in Uganda in 2003 to that in 2009?
Your response must be concise. 1. What is the ratio of the % of repeaters in European Union in 2003 to that in 2010?
Offer a very short reply. 1.02. What is the ratio of the % of repeaters in High income: nonOECD in 2003 to that in 2010?
Keep it short and to the point. 1.1. What is the ratio of the % of repeaters in Chad in 2003 to that in 2010?
Keep it short and to the point. 1.08. What is the ratio of the % of repeaters in Uganda in 2003 to that in 2010?
Provide a short and direct response. 0.89. What is the ratio of the % of repeaters of European Union in 2004 to that in 2006?
Provide a short and direct response. 1. What is the ratio of the % of repeaters of High income: nonOECD in 2004 to that in 2006?
Your answer should be very brief. 0.97. What is the ratio of the % of repeaters in Uganda in 2004 to that in 2006?
Keep it short and to the point. 0.79. What is the ratio of the % of repeaters of European Union in 2004 to that in 2009?
Make the answer very short. 1.06. What is the ratio of the % of repeaters of High income: nonOECD in 2004 to that in 2009?
Ensure brevity in your answer.  1.07. What is the ratio of the % of repeaters of Chad in 2004 to that in 2009?
Ensure brevity in your answer.  1.01. What is the ratio of the % of repeaters of Uganda in 2004 to that in 2009?
Ensure brevity in your answer.  0.94. What is the ratio of the % of repeaters in European Union in 2004 to that in 2010?
Offer a terse response. 1.08. What is the ratio of the % of repeaters of High income: nonOECD in 2004 to that in 2010?
Make the answer very short. 1.14. What is the ratio of the % of repeaters of Chad in 2004 to that in 2010?
Offer a terse response. 0.98. What is the ratio of the % of repeaters of Uganda in 2004 to that in 2010?
Provide a short and direct response. 0.84. What is the ratio of the % of repeaters in European Union in 2006 to that in 2009?
Offer a terse response. 1.06. What is the ratio of the % of repeaters of High income: nonOECD in 2006 to that in 2009?
Offer a terse response. 1.1. What is the ratio of the % of repeaters of Chad in 2006 to that in 2009?
Provide a short and direct response. 0.99. What is the ratio of the % of repeaters in Uganda in 2006 to that in 2009?
Your answer should be compact. 1.19. What is the ratio of the % of repeaters of European Union in 2006 to that in 2010?
Offer a terse response. 1.08. What is the ratio of the % of repeaters of High income: nonOECD in 2006 to that in 2010?
Your response must be concise. 1.17. What is the ratio of the % of repeaters of Chad in 2006 to that in 2010?
Give a very brief answer. 0.96. What is the ratio of the % of repeaters of Uganda in 2006 to that in 2010?
Provide a short and direct response. 1.06. What is the ratio of the % of repeaters of European Union in 2009 to that in 2010?
Give a very brief answer. 1.02. What is the ratio of the % of repeaters in High income: nonOECD in 2009 to that in 2010?
Provide a short and direct response. 1.07. What is the ratio of the % of repeaters of Chad in 2009 to that in 2010?
Provide a short and direct response. 0.97. What is the ratio of the % of repeaters of Uganda in 2009 to that in 2010?
Your response must be concise. 0.89. What is the difference between the highest and the second highest % of repeaters in European Union?
Give a very brief answer. 0.15. What is the difference between the highest and the second highest % of repeaters of High income: nonOECD?
Provide a succinct answer. 0.14. What is the difference between the highest and the second highest % of repeaters of Chad?
Offer a terse response. 1.56. What is the difference between the highest and the second highest % of repeaters in Uganda?
Give a very brief answer. 0.14. What is the difference between the highest and the lowest % of repeaters in European Union?
Give a very brief answer. 0.49. What is the difference between the highest and the lowest % of repeaters in High income: nonOECD?
Ensure brevity in your answer.  0.68. What is the difference between the highest and the lowest % of repeaters of Chad?
Provide a short and direct response. 5.1. What is the difference between the highest and the lowest % of repeaters of Uganda?
Your answer should be compact. 0.53. 